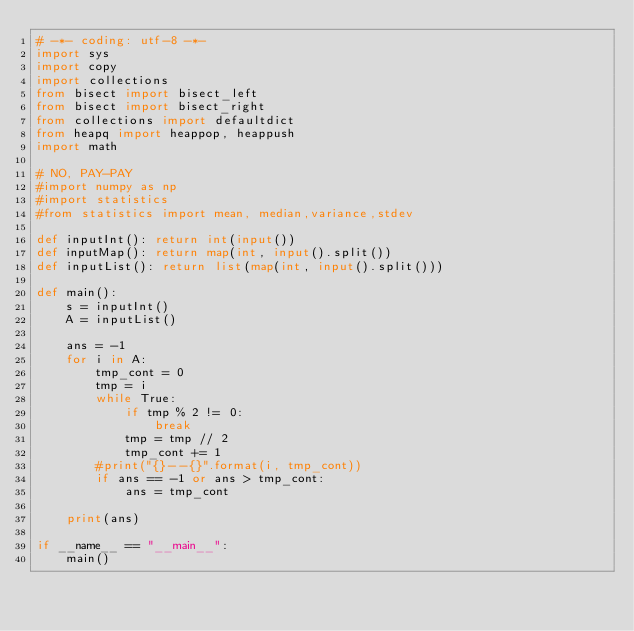Convert code to text. <code><loc_0><loc_0><loc_500><loc_500><_Python_># -*- coding: utf-8 -*-
import sys
import copy
import collections
from bisect import bisect_left
from bisect import bisect_right
from collections import defaultdict
from heapq import heappop, heappush
import math

# NO, PAY-PAY
#import numpy as np
#import statistics
#from statistics import mean, median,variance,stdev

def inputInt(): return int(input())
def inputMap(): return map(int, input().split())
def inputList(): return list(map(int, input().split()))
 
def main():
    s = inputInt()
    A = inputList()
    
    ans = -1
    for i in A:
        tmp_cont = 0
        tmp = i
        while True:
            if tmp % 2 != 0:
                break
            tmp = tmp // 2
            tmp_cont += 1
        #print("{}--{}".format(i, tmp_cont))
        if ans == -1 or ans > tmp_cont:
            ans = tmp_cont
        
    print(ans)
            	
if __name__ == "__main__":
	main()
</code> 